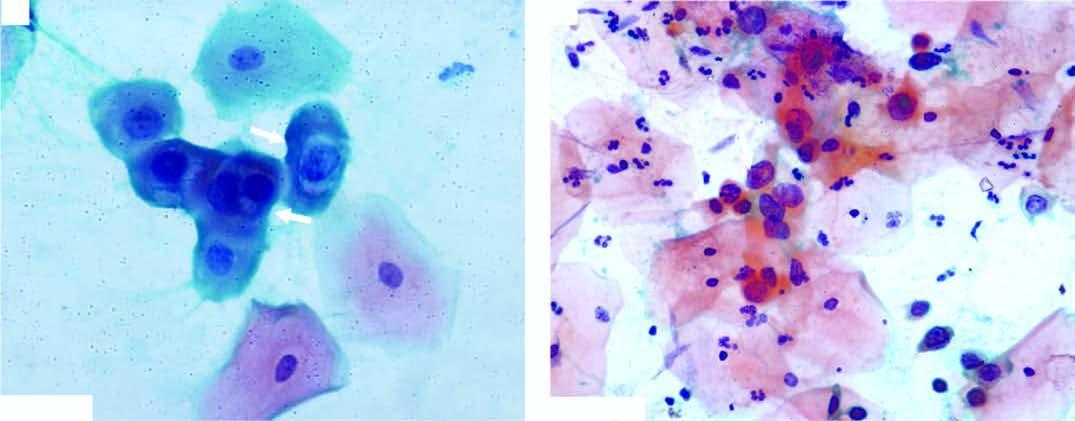does the smear show koilocytes having abundant vacuolated cytoplasm and nuclear enlargement?
Answer the question using a single word or phrase. Yes 